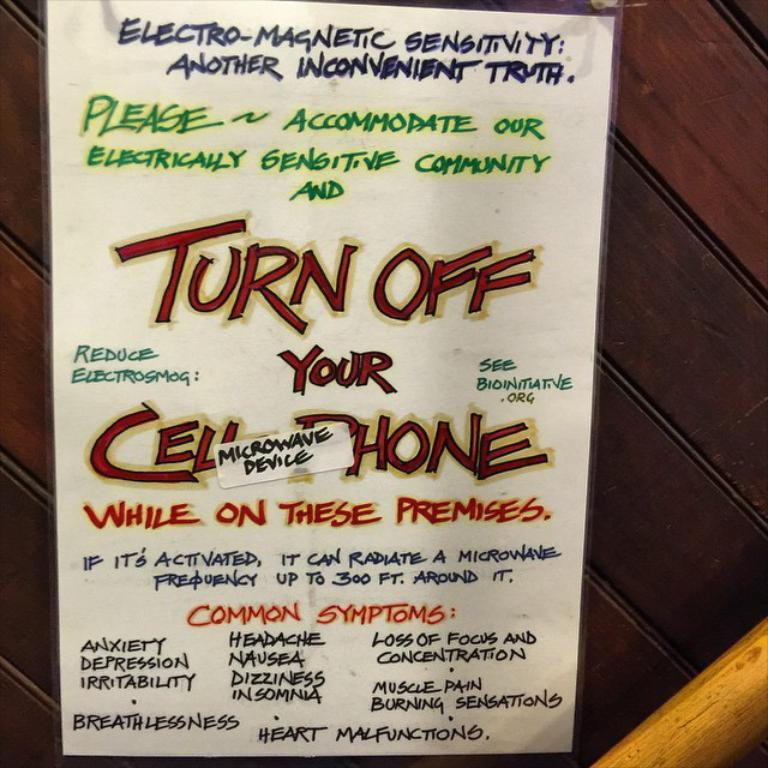<image>
Summarize the visual content of the image. A sign tells you to turn off your cell phone due to electro-magnetic sensitivity. 